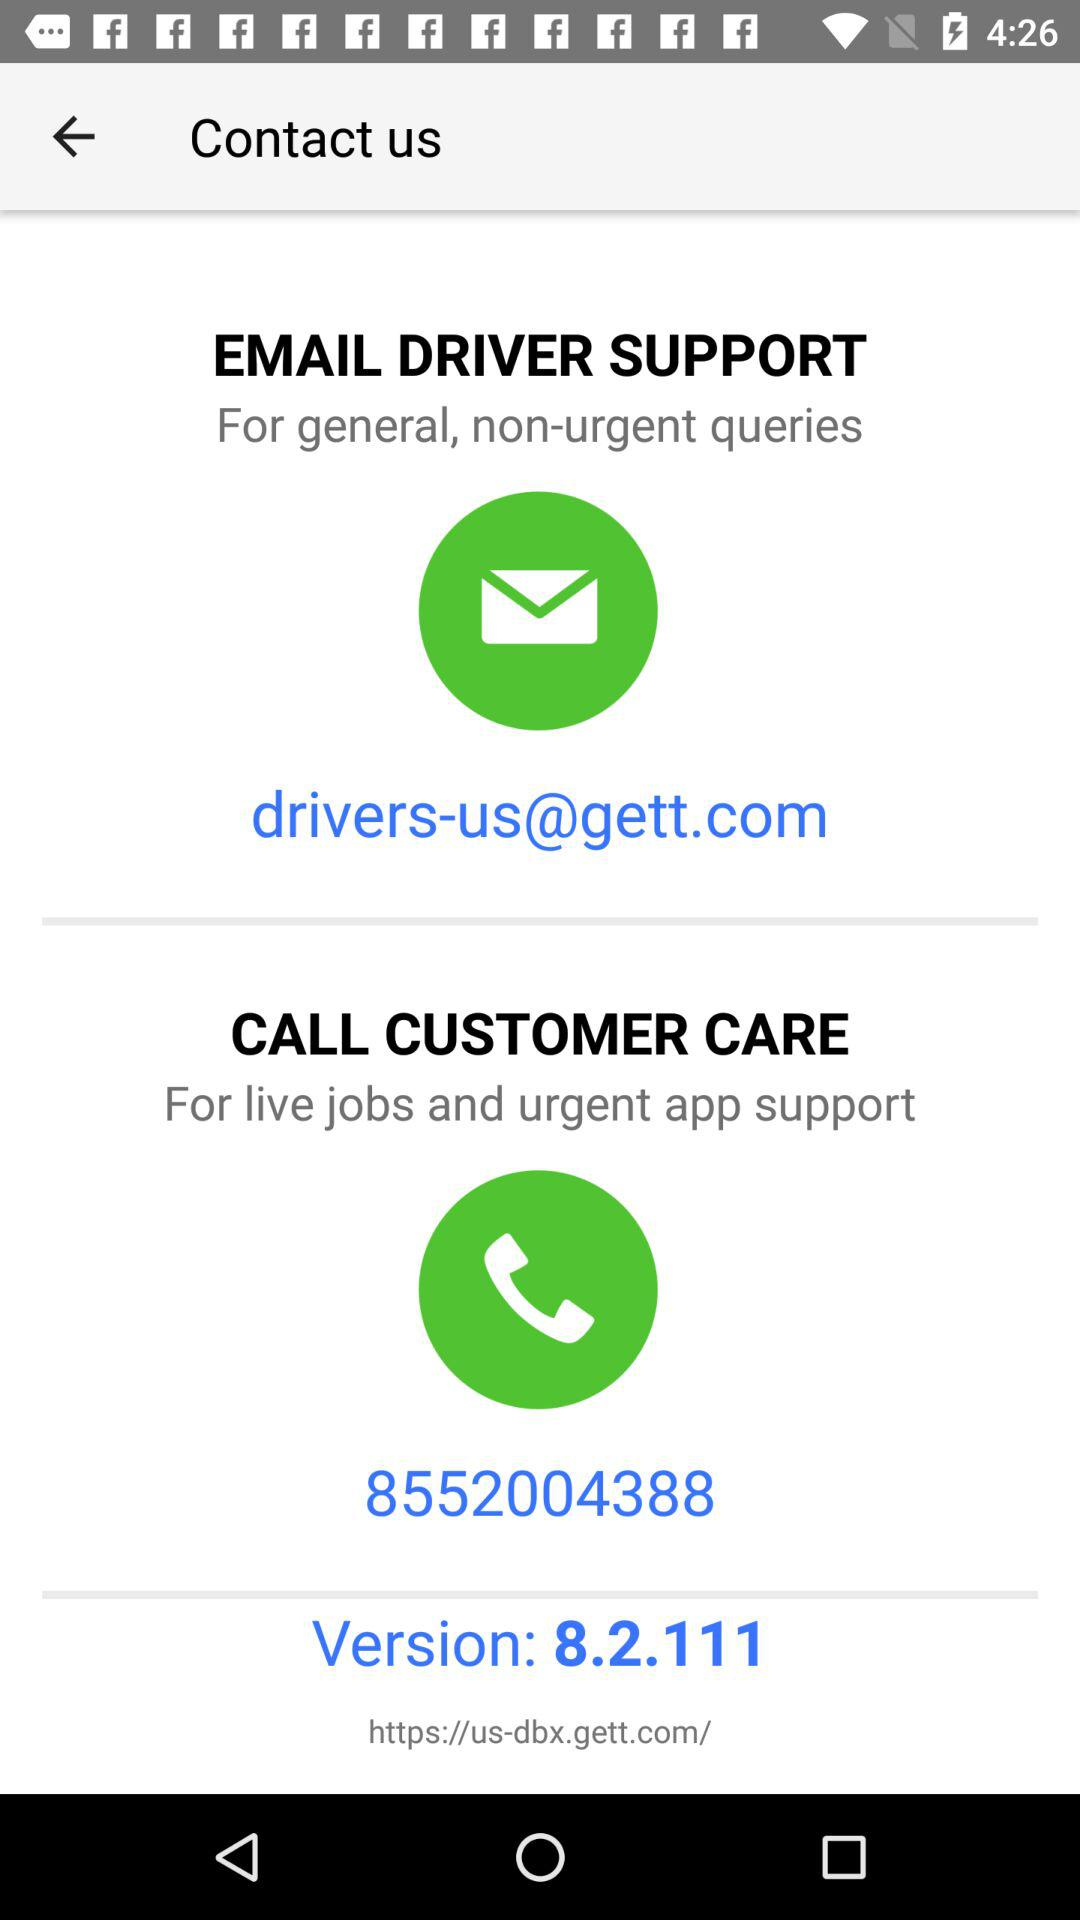Which version is it? It is version 8.2.111. 